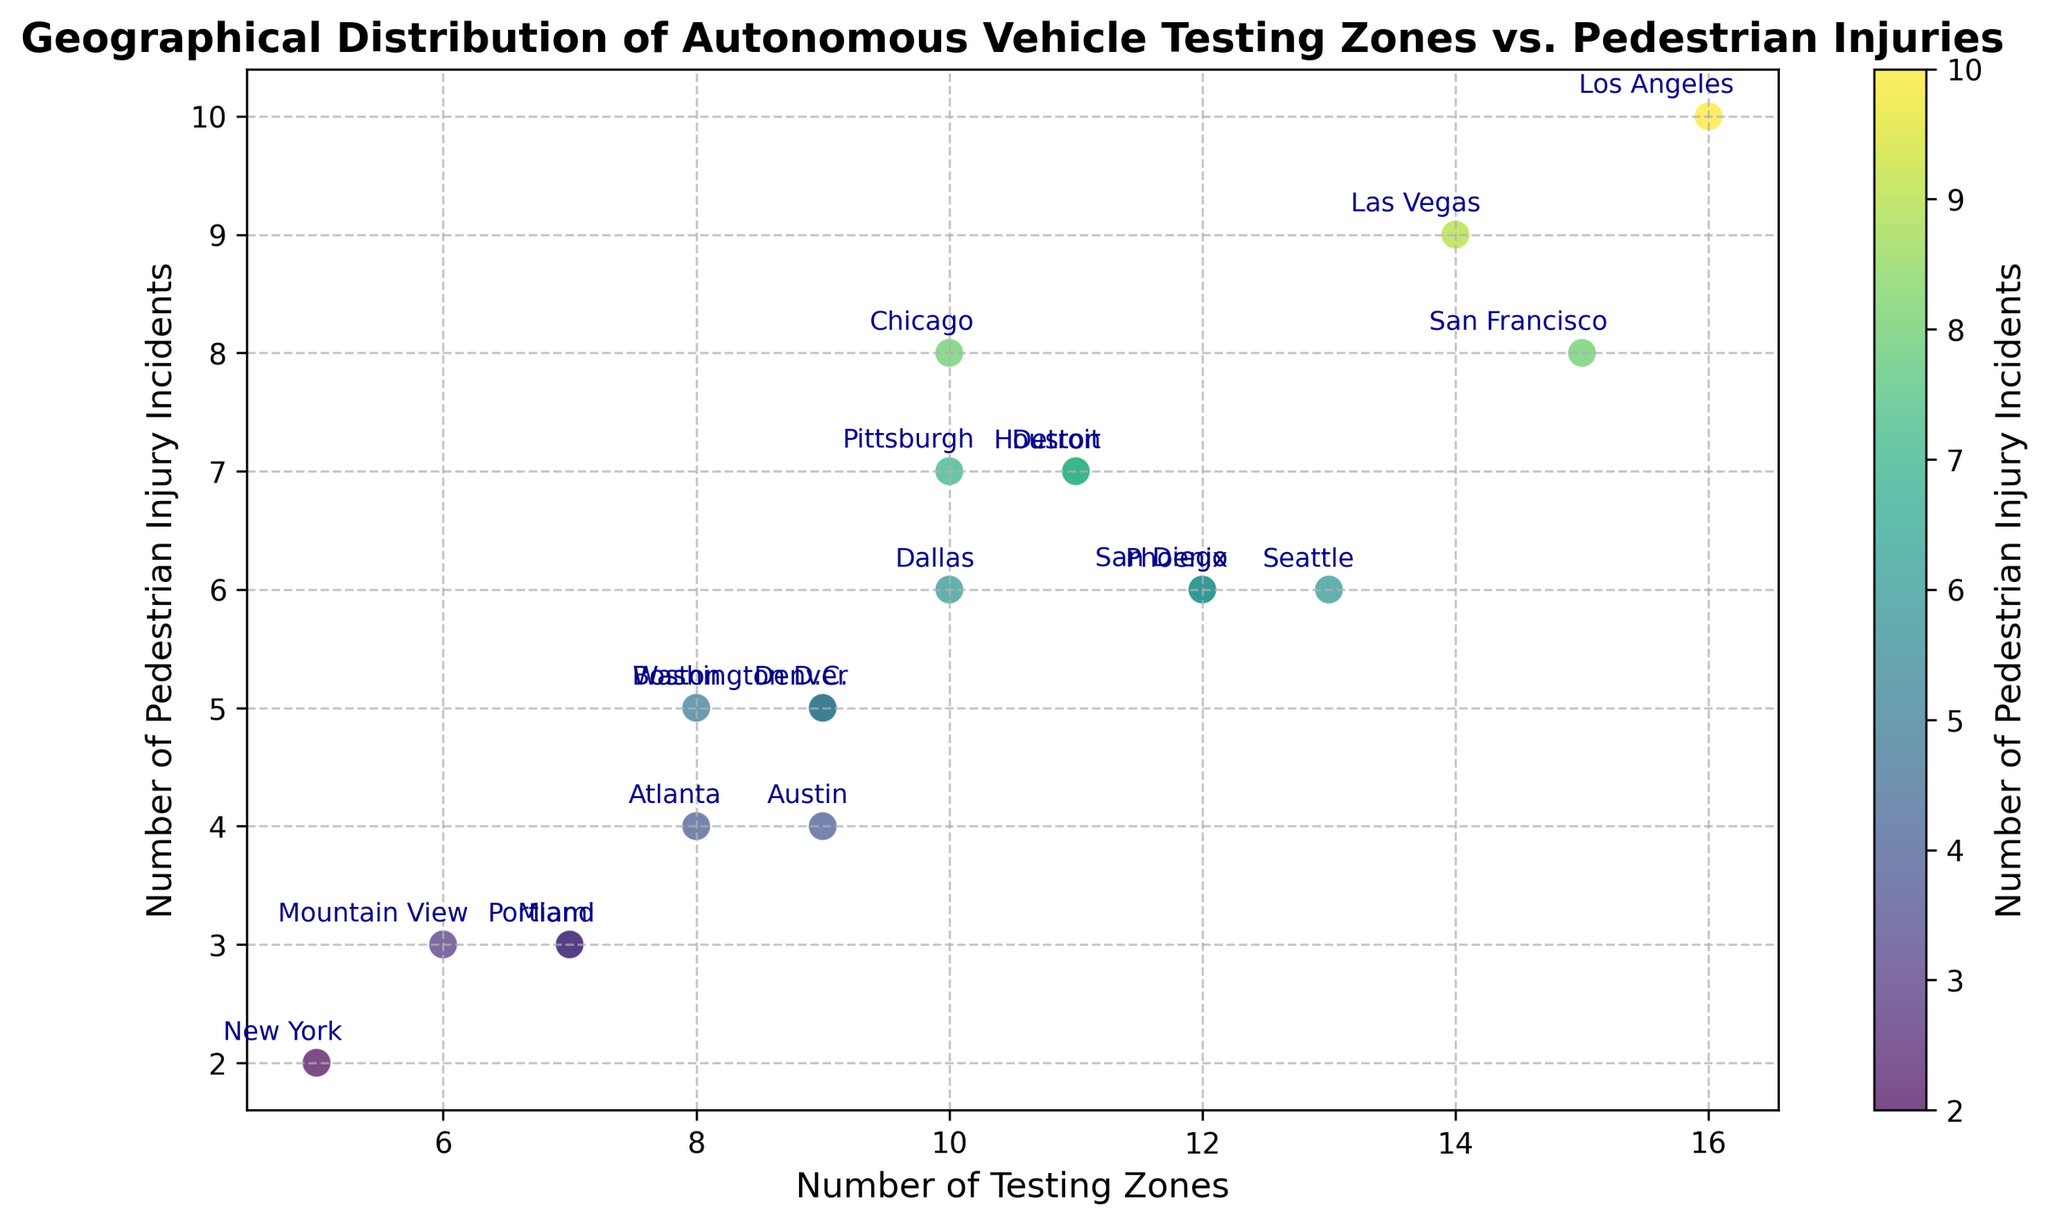Which city has the highest number of pedestrian injury incidents? To determine the city with the highest number of pedestrian injury incidents, look for the data point with the largest value on the y-axis. In this case, the city of Los Angeles has the maximum number of incidents, at 10.
Answer: Los Angeles Which cities have exactly 5 pedestrian injury incidents? To find the cities with exactly 5 incidents, locate the data points that align with 5 on the y-axis. The cities are Boston, Washington D.C., Denver, and Portland.
Answer: Boston, Washington D.C., Denver, Portland How many more testing zones does Los Angeles have compared to New York? First, find the number of testing zones in Los Angeles (16) and New York (5). Then, subtract the number of testing zones in New York from Los Angeles: 16 - 5 = 11.
Answer: 11 Which city has the highest number of testing zones and how many incidents have been reported there? Identify the city with the highest number of testing zones by looking at the highest value on the x-axis, which is Los Angeles with 16 zones. The number of incidents reported there is 10.
Answer: Los Angeles, 10 Is there a city with 11 testing zones and how many pedestrian incidents are reported there? Check if there is a data point where the x-axis value is 11. There are two cities: Detroit and Houston. Both cities have reported 7 pedestrian incidents each.
Answer: Detroit and Houston, 7 Compare the number of testing zones and incidents between San Francisco and Chicago. Which city has more testing zones and more incidents? San Francisco has 15 testing zones and 8 incidents. Chicago has 10 testing zones and 8 incidents. Thus, San Francisco has more testing zones, and both cities have the same number of incidents.
Answer: San Francisco, same number of incidents Which cities have more than 10 testing zones? Identify data points where the x-axis value is greater than 10. The cities are San Francisco, Phoenix, Los Angeles, Las Vegas, and Seattle.
Answer: San Francisco, Phoenix, Los Angeles, Las Vegas, Seattle What is the total number of pedestrian injury incidents in cities with fewer than 10 testing zones? Identify cities with fewer than 10 testing zones and sum their incidents: Boston (5), Mountain View (3), Miami (3), New York (2), Washington D.C. (5), Portland (3), Denver (5), and Atlanta (4). The total is 5 + 3 + 3 + 2 + 5 + 3 + 5 + 4 = 30.
Answer: 30 From the scatter plot, does there appear to be a correlation between the number of testing zones and pedestrian injury incidents? Observe the overall trend of the data points. While there seems to be a slight upward trend showing more incidents with more testing zones, the relationship is not perfectly linear.
Answer: Slight upward trend Which city has the lowest number of pedestrian incidents and how many testing zones does it have? Look for the data point with the lowest value on the y-axis. New York has the lowest number of pedestrian incidents, at 2, and it has 5 testing zones.
Answer: New York, 5 